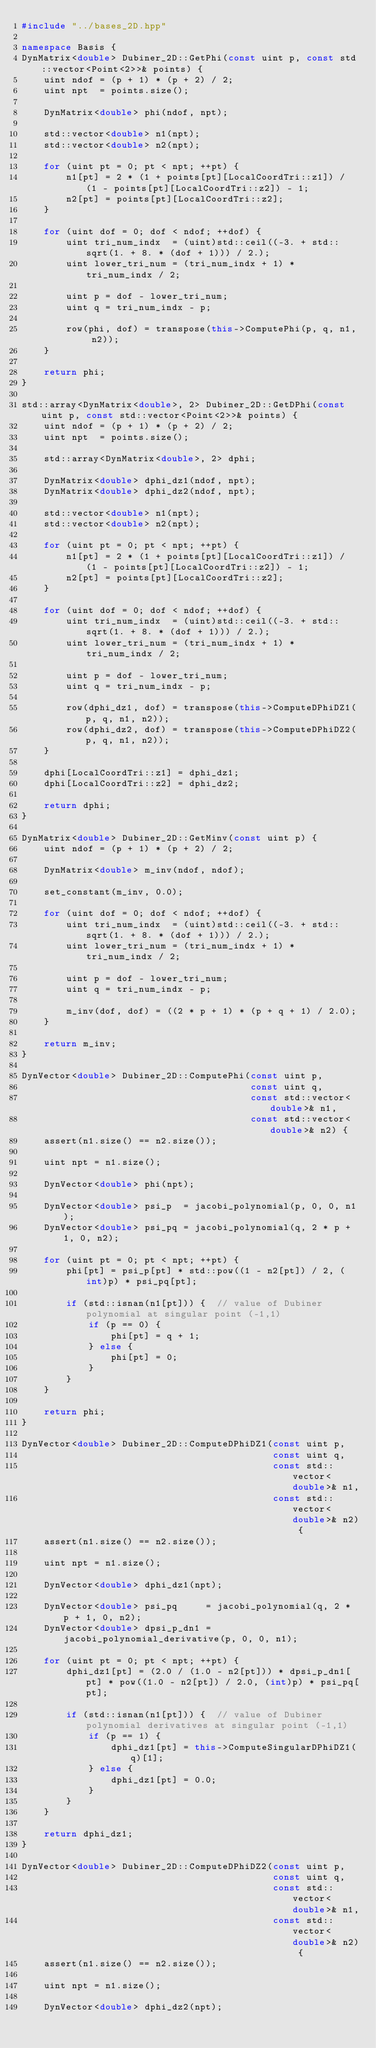Convert code to text. <code><loc_0><loc_0><loc_500><loc_500><_C++_>#include "../bases_2D.hpp"

namespace Basis {
DynMatrix<double> Dubiner_2D::GetPhi(const uint p, const std::vector<Point<2>>& points) {
    uint ndof = (p + 1) * (p + 2) / 2;
    uint npt  = points.size();

    DynMatrix<double> phi(ndof, npt);

    std::vector<double> n1(npt);
    std::vector<double> n2(npt);

    for (uint pt = 0; pt < npt; ++pt) {
        n1[pt] = 2 * (1 + points[pt][LocalCoordTri::z1]) / (1 - points[pt][LocalCoordTri::z2]) - 1;
        n2[pt] = points[pt][LocalCoordTri::z2];
    }

    for (uint dof = 0; dof < ndof; ++dof) {
        uint tri_num_indx  = (uint)std::ceil((-3. + std::sqrt(1. + 8. * (dof + 1))) / 2.);
        uint lower_tri_num = (tri_num_indx + 1) * tri_num_indx / 2;

        uint p = dof - lower_tri_num;
        uint q = tri_num_indx - p;

        row(phi, dof) = transpose(this->ComputePhi(p, q, n1, n2));
    }

    return phi;
}

std::array<DynMatrix<double>, 2> Dubiner_2D::GetDPhi(const uint p, const std::vector<Point<2>>& points) {
    uint ndof = (p + 1) * (p + 2) / 2;
    uint npt  = points.size();

    std::array<DynMatrix<double>, 2> dphi;

    DynMatrix<double> dphi_dz1(ndof, npt);
    DynMatrix<double> dphi_dz2(ndof, npt);

    std::vector<double> n1(npt);
    std::vector<double> n2(npt);

    for (uint pt = 0; pt < npt; ++pt) {
        n1[pt] = 2 * (1 + points[pt][LocalCoordTri::z1]) / (1 - points[pt][LocalCoordTri::z2]) - 1;
        n2[pt] = points[pt][LocalCoordTri::z2];
    }

    for (uint dof = 0; dof < ndof; ++dof) {
        uint tri_num_indx  = (uint)std::ceil((-3. + std::sqrt(1. + 8. * (dof + 1))) / 2.);
        uint lower_tri_num = (tri_num_indx + 1) * tri_num_indx / 2;

        uint p = dof - lower_tri_num;
        uint q = tri_num_indx - p;

        row(dphi_dz1, dof) = transpose(this->ComputeDPhiDZ1(p, q, n1, n2));
        row(dphi_dz2, dof) = transpose(this->ComputeDPhiDZ2(p, q, n1, n2));
    }

    dphi[LocalCoordTri::z1] = dphi_dz1;
    dphi[LocalCoordTri::z2] = dphi_dz2;

    return dphi;
}

DynMatrix<double> Dubiner_2D::GetMinv(const uint p) {
    uint ndof = (p + 1) * (p + 2) / 2;

    DynMatrix<double> m_inv(ndof, ndof);

    set_constant(m_inv, 0.0);

    for (uint dof = 0; dof < ndof; ++dof) {
        uint tri_num_indx  = (uint)std::ceil((-3. + std::sqrt(1. + 8. * (dof + 1))) / 2.);
        uint lower_tri_num = (tri_num_indx + 1) * tri_num_indx / 2;

        uint p = dof - lower_tri_num;
        uint q = tri_num_indx - p;

        m_inv(dof, dof) = ((2 * p + 1) * (p + q + 1) / 2.0);
    }

    return m_inv;
}

DynVector<double> Dubiner_2D::ComputePhi(const uint p,
                                         const uint q,
                                         const std::vector<double>& n1,
                                         const std::vector<double>& n2) {
    assert(n1.size() == n2.size());

    uint npt = n1.size();

    DynVector<double> phi(npt);

    DynVector<double> psi_p  = jacobi_polynomial(p, 0, 0, n1);
    DynVector<double> psi_pq = jacobi_polynomial(q, 2 * p + 1, 0, n2);

    for (uint pt = 0; pt < npt; ++pt) {
        phi[pt] = psi_p[pt] * std::pow((1 - n2[pt]) / 2, (int)p) * psi_pq[pt];

        if (std::isnan(n1[pt])) {  // value of Dubiner polynomial at singular point (-1,1)
            if (p == 0) {
                phi[pt] = q + 1;
            } else {
                phi[pt] = 0;
            }
        }
    }

    return phi;
}

DynVector<double> Dubiner_2D::ComputeDPhiDZ1(const uint p,
                                             const uint q,
                                             const std::vector<double>& n1,
                                             const std::vector<double>& n2) {
    assert(n1.size() == n2.size());

    uint npt = n1.size();

    DynVector<double> dphi_dz1(npt);

    DynVector<double> psi_pq     = jacobi_polynomial(q, 2 * p + 1, 0, n2);
    DynVector<double> dpsi_p_dn1 = jacobi_polynomial_derivative(p, 0, 0, n1);

    for (uint pt = 0; pt < npt; ++pt) {
        dphi_dz1[pt] = (2.0 / (1.0 - n2[pt])) * dpsi_p_dn1[pt] * pow((1.0 - n2[pt]) / 2.0, (int)p) * psi_pq[pt];

        if (std::isnan(n1[pt])) {  // value of Dubiner polynomial derivatives at singular point (-1,1)
            if (p == 1) {
                dphi_dz1[pt] = this->ComputeSingularDPhiDZ1(q)[1];
            } else {
                dphi_dz1[pt] = 0.0;
            }
        }
    }

    return dphi_dz1;
}

DynVector<double> Dubiner_2D::ComputeDPhiDZ2(const uint p,
                                             const uint q,
                                             const std::vector<double>& n1,
                                             const std::vector<double>& n2) {
    assert(n1.size() == n2.size());

    uint npt = n1.size();

    DynVector<double> dphi_dz2(npt);
</code> 